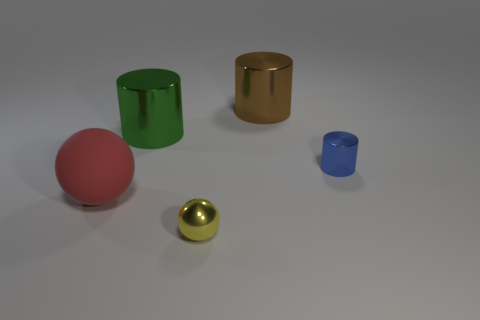Subtract all green shiny cylinders. How many cylinders are left? 2 Subtract all red spheres. How many spheres are left? 1 Subtract all balls. How many objects are left? 3 Add 3 large cylinders. How many large cylinders are left? 5 Add 2 brown metallic cylinders. How many brown metallic cylinders exist? 3 Add 4 blue metallic objects. How many objects exist? 9 Subtract 0 brown blocks. How many objects are left? 5 Subtract 1 cylinders. How many cylinders are left? 2 Subtract all yellow cylinders. Subtract all yellow balls. How many cylinders are left? 3 Subtract all green blocks. How many gray balls are left? 0 